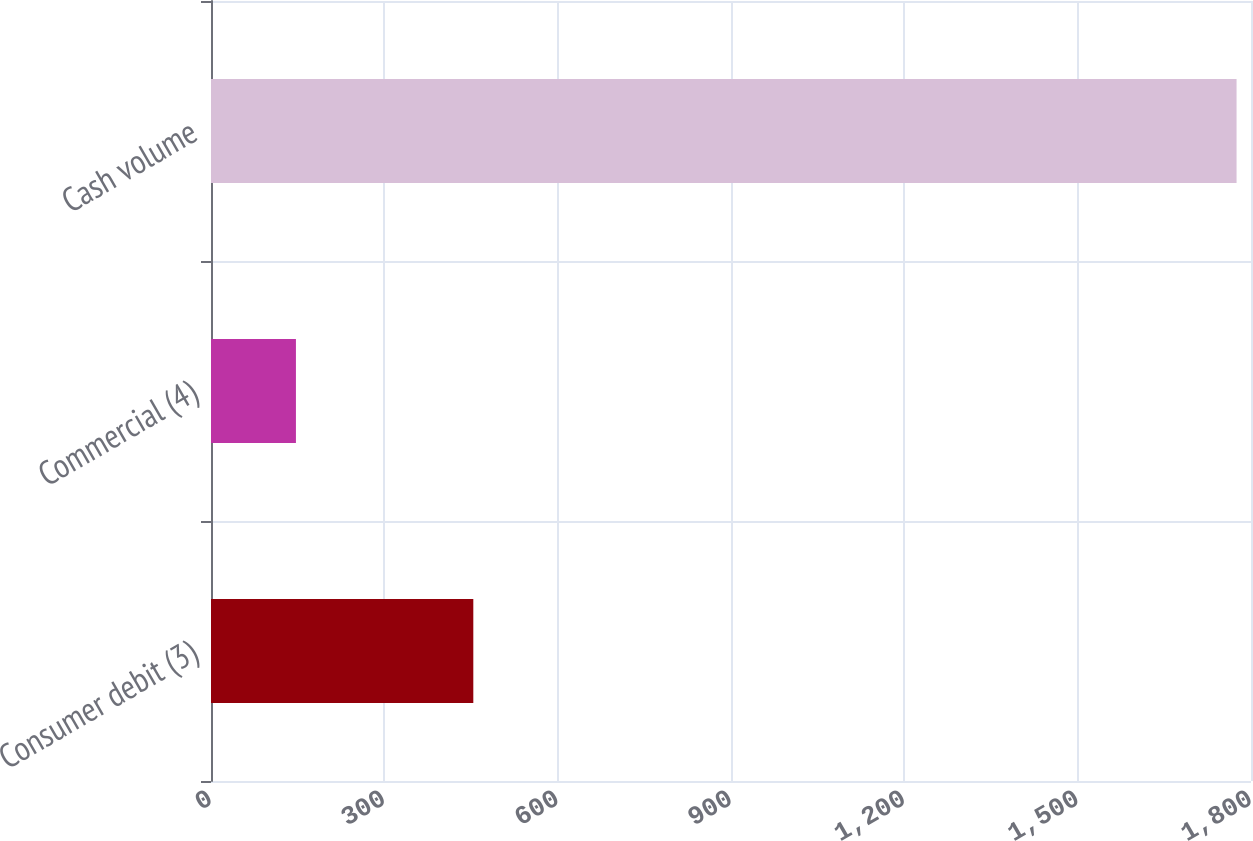Convert chart to OTSL. <chart><loc_0><loc_0><loc_500><loc_500><bar_chart><fcel>Consumer debit (3)<fcel>Commercial (4)<fcel>Cash volume<nl><fcel>454<fcel>147<fcel>1775<nl></chart> 